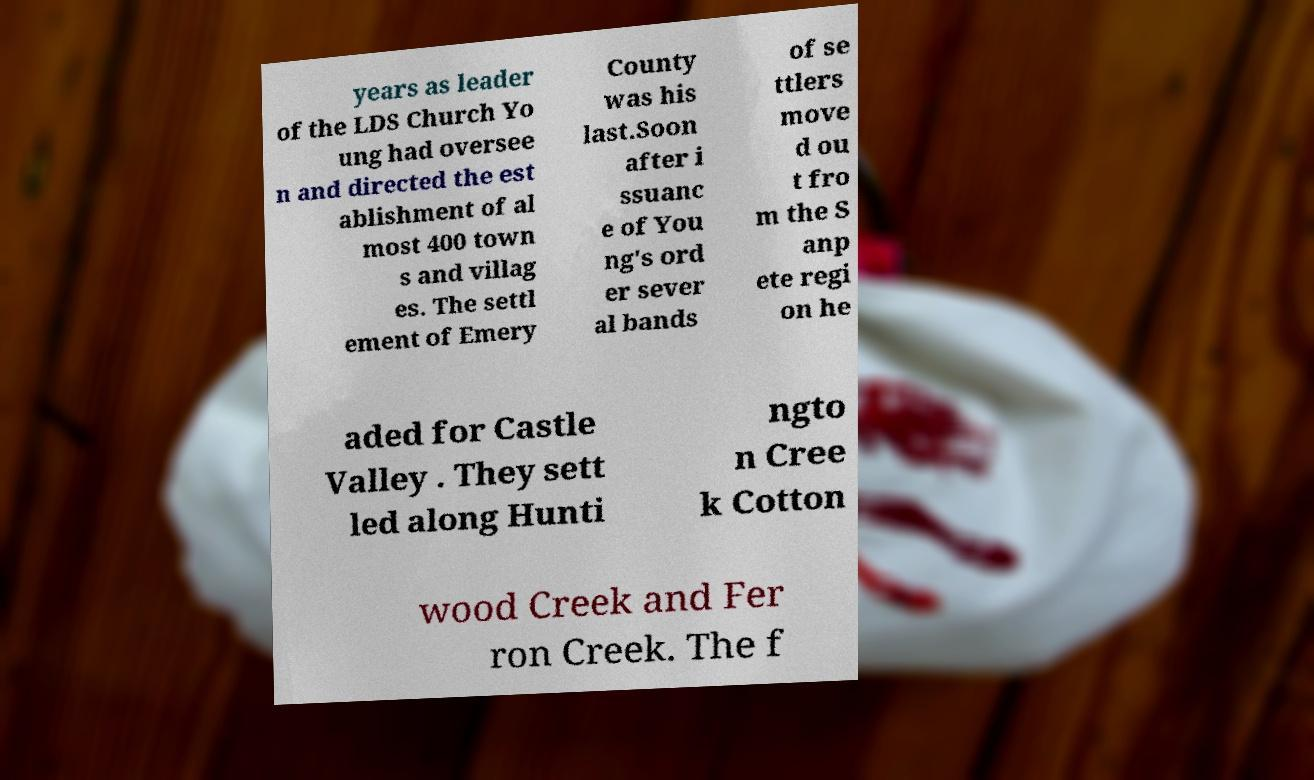Please identify and transcribe the text found in this image. years as leader of the LDS Church Yo ung had oversee n and directed the est ablishment of al most 400 town s and villag es. The settl ement of Emery County was his last.Soon after i ssuanc e of You ng's ord er sever al bands of se ttlers move d ou t fro m the S anp ete regi on he aded for Castle Valley . They sett led along Hunti ngto n Cree k Cotton wood Creek and Fer ron Creek. The f 